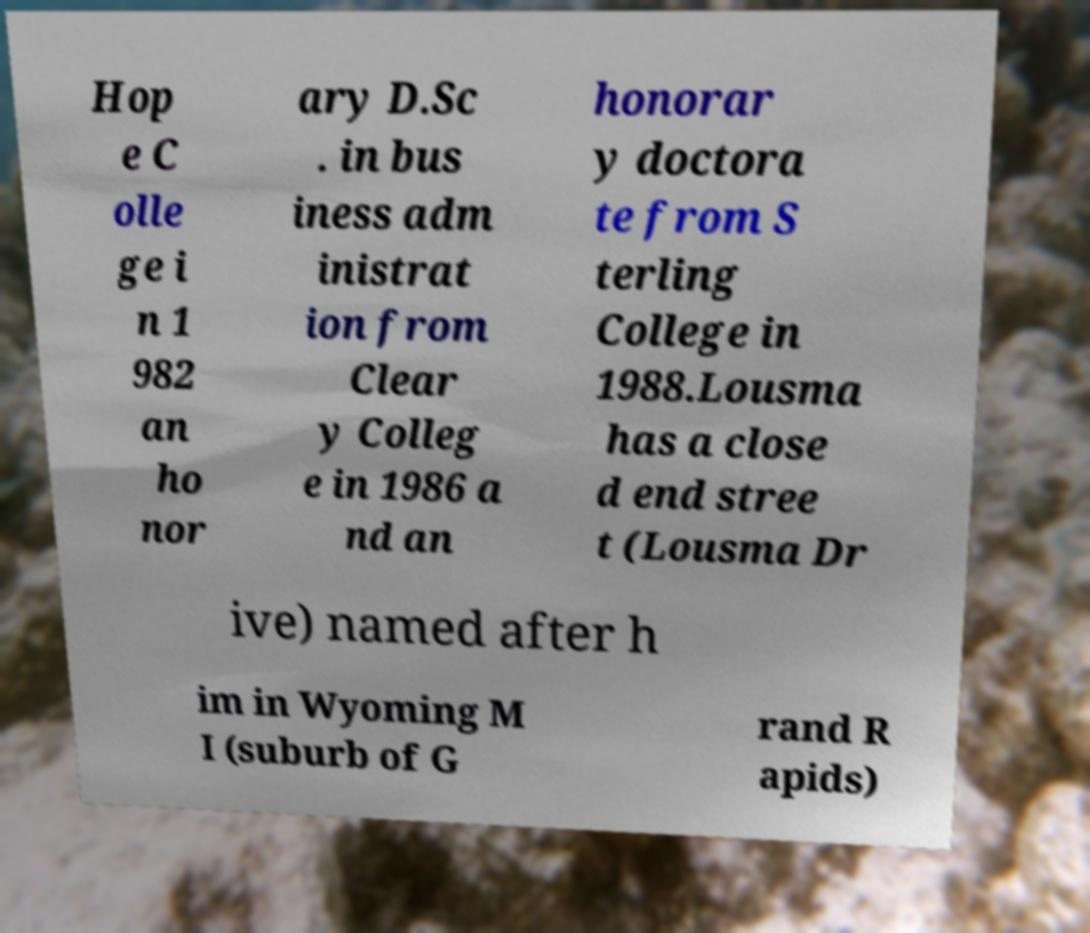Could you extract and type out the text from this image? Hop e C olle ge i n 1 982 an ho nor ary D.Sc . in bus iness adm inistrat ion from Clear y Colleg e in 1986 a nd an honorar y doctora te from S terling College in 1988.Lousma has a close d end stree t (Lousma Dr ive) named after h im in Wyoming M I (suburb of G rand R apids) 